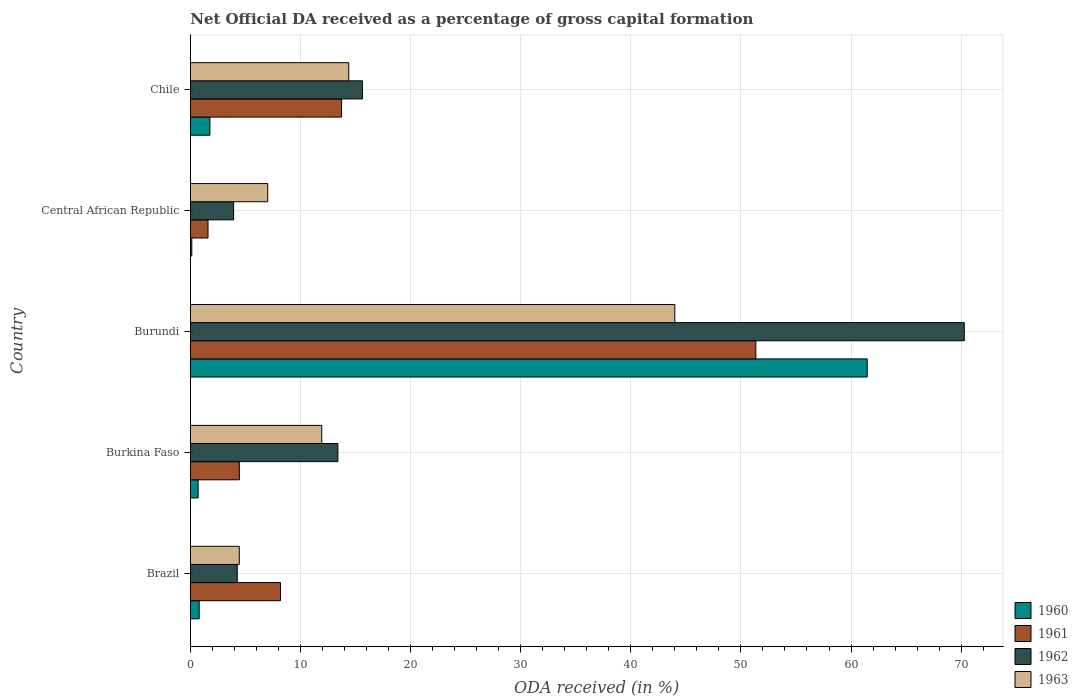How many groups of bars are there?
Offer a terse response. 5. Are the number of bars per tick equal to the number of legend labels?
Give a very brief answer. Yes. Are the number of bars on each tick of the Y-axis equal?
Make the answer very short. Yes. How many bars are there on the 1st tick from the top?
Provide a short and direct response. 4. How many bars are there on the 1st tick from the bottom?
Your response must be concise. 4. What is the label of the 1st group of bars from the top?
Offer a terse response. Chile. In how many cases, is the number of bars for a given country not equal to the number of legend labels?
Your answer should be very brief. 0. What is the net ODA received in 1960 in Burkina Faso?
Your answer should be compact. 0.71. Across all countries, what is the maximum net ODA received in 1961?
Ensure brevity in your answer.  51.36. Across all countries, what is the minimum net ODA received in 1962?
Provide a short and direct response. 3.93. In which country was the net ODA received in 1962 maximum?
Offer a very short reply. Burundi. In which country was the net ODA received in 1963 minimum?
Provide a short and direct response. Brazil. What is the total net ODA received in 1960 in the graph?
Keep it short and to the point. 64.9. What is the difference between the net ODA received in 1962 in Burundi and that in Chile?
Provide a short and direct response. 54.66. What is the difference between the net ODA received in 1962 in Chile and the net ODA received in 1960 in Burkina Faso?
Provide a succinct answer. 14.92. What is the average net ODA received in 1962 per country?
Ensure brevity in your answer.  21.5. What is the difference between the net ODA received in 1962 and net ODA received in 1963 in Burundi?
Make the answer very short. 26.29. What is the ratio of the net ODA received in 1961 in Burkina Faso to that in Chile?
Keep it short and to the point. 0.32. What is the difference between the highest and the second highest net ODA received in 1960?
Provide a short and direct response. 59.69. What is the difference between the highest and the lowest net ODA received in 1961?
Offer a very short reply. 49.75. In how many countries, is the net ODA received in 1962 greater than the average net ODA received in 1962 taken over all countries?
Keep it short and to the point. 1. Is it the case that in every country, the sum of the net ODA received in 1960 and net ODA received in 1961 is greater than the sum of net ODA received in 1962 and net ODA received in 1963?
Make the answer very short. No. What does the 4th bar from the top in Chile represents?
Your answer should be very brief. 1960. How many bars are there?
Provide a succinct answer. 20. Are the values on the major ticks of X-axis written in scientific E-notation?
Your answer should be very brief. No. Does the graph contain any zero values?
Give a very brief answer. No. Does the graph contain grids?
Give a very brief answer. Yes. How many legend labels are there?
Keep it short and to the point. 4. What is the title of the graph?
Offer a very short reply. Net Official DA received as a percentage of gross capital formation. Does "1977" appear as one of the legend labels in the graph?
Offer a terse response. No. What is the label or title of the X-axis?
Your answer should be very brief. ODA received (in %). What is the label or title of the Y-axis?
Provide a short and direct response. Country. What is the ODA received (in %) of 1960 in Brazil?
Offer a very short reply. 0.81. What is the ODA received (in %) of 1961 in Brazil?
Your answer should be compact. 8.19. What is the ODA received (in %) in 1962 in Brazil?
Offer a very short reply. 4.26. What is the ODA received (in %) in 1963 in Brazil?
Give a very brief answer. 4.45. What is the ODA received (in %) in 1960 in Burkina Faso?
Give a very brief answer. 0.71. What is the ODA received (in %) in 1961 in Burkina Faso?
Your answer should be very brief. 4.45. What is the ODA received (in %) of 1962 in Burkina Faso?
Offer a very short reply. 13.4. What is the ODA received (in %) of 1963 in Burkina Faso?
Offer a very short reply. 11.94. What is the ODA received (in %) in 1960 in Burundi?
Your answer should be very brief. 61.47. What is the ODA received (in %) of 1961 in Burundi?
Make the answer very short. 51.36. What is the ODA received (in %) in 1962 in Burundi?
Make the answer very short. 70.29. What is the ODA received (in %) in 1963 in Burundi?
Provide a succinct answer. 44. What is the ODA received (in %) of 1960 in Central African Republic?
Your answer should be very brief. 0.14. What is the ODA received (in %) of 1961 in Central African Republic?
Make the answer very short. 1.61. What is the ODA received (in %) in 1962 in Central African Republic?
Make the answer very short. 3.93. What is the ODA received (in %) in 1963 in Central African Republic?
Provide a short and direct response. 7.03. What is the ODA received (in %) of 1960 in Chile?
Offer a terse response. 1.78. What is the ODA received (in %) in 1961 in Chile?
Ensure brevity in your answer.  13.73. What is the ODA received (in %) of 1962 in Chile?
Your answer should be very brief. 15.63. What is the ODA received (in %) in 1963 in Chile?
Your answer should be compact. 14.39. Across all countries, what is the maximum ODA received (in %) in 1960?
Make the answer very short. 61.47. Across all countries, what is the maximum ODA received (in %) of 1961?
Your answer should be very brief. 51.36. Across all countries, what is the maximum ODA received (in %) in 1962?
Offer a terse response. 70.29. Across all countries, what is the minimum ODA received (in %) in 1960?
Your answer should be compact. 0.14. Across all countries, what is the minimum ODA received (in %) of 1961?
Provide a succinct answer. 1.61. Across all countries, what is the minimum ODA received (in %) in 1962?
Offer a very short reply. 3.93. Across all countries, what is the minimum ODA received (in %) in 1963?
Your response must be concise. 4.45. What is the total ODA received (in %) in 1960 in the graph?
Provide a succinct answer. 64.9. What is the total ODA received (in %) of 1961 in the graph?
Your answer should be compact. 79.35. What is the total ODA received (in %) of 1962 in the graph?
Provide a short and direct response. 107.52. What is the total ODA received (in %) in 1963 in the graph?
Your answer should be very brief. 81.81. What is the difference between the ODA received (in %) in 1960 in Brazil and that in Burkina Faso?
Provide a short and direct response. 0.1. What is the difference between the ODA received (in %) of 1961 in Brazil and that in Burkina Faso?
Offer a terse response. 3.74. What is the difference between the ODA received (in %) of 1962 in Brazil and that in Burkina Faso?
Provide a short and direct response. -9.14. What is the difference between the ODA received (in %) of 1963 in Brazil and that in Burkina Faso?
Keep it short and to the point. -7.49. What is the difference between the ODA received (in %) in 1960 in Brazil and that in Burundi?
Your answer should be compact. -60.66. What is the difference between the ODA received (in %) of 1961 in Brazil and that in Burundi?
Make the answer very short. -43.17. What is the difference between the ODA received (in %) in 1962 in Brazil and that in Burundi?
Your response must be concise. -66.02. What is the difference between the ODA received (in %) of 1963 in Brazil and that in Burundi?
Provide a short and direct response. -39.55. What is the difference between the ODA received (in %) in 1960 in Brazil and that in Central African Republic?
Provide a short and direct response. 0.67. What is the difference between the ODA received (in %) in 1961 in Brazil and that in Central African Republic?
Offer a terse response. 6.58. What is the difference between the ODA received (in %) of 1962 in Brazil and that in Central African Republic?
Provide a short and direct response. 0.33. What is the difference between the ODA received (in %) of 1963 in Brazil and that in Central African Republic?
Make the answer very short. -2.58. What is the difference between the ODA received (in %) in 1960 in Brazil and that in Chile?
Provide a short and direct response. -0.97. What is the difference between the ODA received (in %) in 1961 in Brazil and that in Chile?
Your answer should be very brief. -5.54. What is the difference between the ODA received (in %) of 1962 in Brazil and that in Chile?
Offer a very short reply. -11.37. What is the difference between the ODA received (in %) of 1963 in Brazil and that in Chile?
Offer a terse response. -9.94. What is the difference between the ODA received (in %) of 1960 in Burkina Faso and that in Burundi?
Your response must be concise. -60.76. What is the difference between the ODA received (in %) in 1961 in Burkina Faso and that in Burundi?
Keep it short and to the point. -46.9. What is the difference between the ODA received (in %) in 1962 in Burkina Faso and that in Burundi?
Your response must be concise. -56.88. What is the difference between the ODA received (in %) in 1963 in Burkina Faso and that in Burundi?
Offer a terse response. -32.06. What is the difference between the ODA received (in %) of 1960 in Burkina Faso and that in Central African Republic?
Provide a short and direct response. 0.57. What is the difference between the ODA received (in %) in 1961 in Burkina Faso and that in Central African Republic?
Make the answer very short. 2.84. What is the difference between the ODA received (in %) in 1962 in Burkina Faso and that in Central African Republic?
Offer a terse response. 9.47. What is the difference between the ODA received (in %) of 1963 in Burkina Faso and that in Central African Republic?
Offer a terse response. 4.91. What is the difference between the ODA received (in %) of 1960 in Burkina Faso and that in Chile?
Your answer should be very brief. -1.07. What is the difference between the ODA received (in %) in 1961 in Burkina Faso and that in Chile?
Your answer should be compact. -9.28. What is the difference between the ODA received (in %) of 1962 in Burkina Faso and that in Chile?
Provide a succinct answer. -2.23. What is the difference between the ODA received (in %) in 1963 in Burkina Faso and that in Chile?
Offer a very short reply. -2.45. What is the difference between the ODA received (in %) of 1960 in Burundi and that in Central African Republic?
Ensure brevity in your answer.  61.33. What is the difference between the ODA received (in %) in 1961 in Burundi and that in Central African Republic?
Offer a very short reply. 49.75. What is the difference between the ODA received (in %) in 1962 in Burundi and that in Central African Republic?
Provide a succinct answer. 66.35. What is the difference between the ODA received (in %) of 1963 in Burundi and that in Central African Republic?
Keep it short and to the point. 36.97. What is the difference between the ODA received (in %) in 1960 in Burundi and that in Chile?
Offer a terse response. 59.69. What is the difference between the ODA received (in %) in 1961 in Burundi and that in Chile?
Your answer should be very brief. 37.62. What is the difference between the ODA received (in %) in 1962 in Burundi and that in Chile?
Keep it short and to the point. 54.66. What is the difference between the ODA received (in %) in 1963 in Burundi and that in Chile?
Keep it short and to the point. 29.61. What is the difference between the ODA received (in %) of 1960 in Central African Republic and that in Chile?
Provide a succinct answer. -1.64. What is the difference between the ODA received (in %) in 1961 in Central African Republic and that in Chile?
Offer a very short reply. -12.12. What is the difference between the ODA received (in %) of 1962 in Central African Republic and that in Chile?
Offer a very short reply. -11.7. What is the difference between the ODA received (in %) in 1963 in Central African Republic and that in Chile?
Offer a very short reply. -7.36. What is the difference between the ODA received (in %) of 1960 in Brazil and the ODA received (in %) of 1961 in Burkina Faso?
Your answer should be very brief. -3.65. What is the difference between the ODA received (in %) of 1960 in Brazil and the ODA received (in %) of 1962 in Burkina Faso?
Make the answer very short. -12.6. What is the difference between the ODA received (in %) in 1960 in Brazil and the ODA received (in %) in 1963 in Burkina Faso?
Make the answer very short. -11.13. What is the difference between the ODA received (in %) of 1961 in Brazil and the ODA received (in %) of 1962 in Burkina Faso?
Your answer should be compact. -5.21. What is the difference between the ODA received (in %) in 1961 in Brazil and the ODA received (in %) in 1963 in Burkina Faso?
Your response must be concise. -3.75. What is the difference between the ODA received (in %) of 1962 in Brazil and the ODA received (in %) of 1963 in Burkina Faso?
Your answer should be very brief. -7.67. What is the difference between the ODA received (in %) of 1960 in Brazil and the ODA received (in %) of 1961 in Burundi?
Ensure brevity in your answer.  -50.55. What is the difference between the ODA received (in %) in 1960 in Brazil and the ODA received (in %) in 1962 in Burundi?
Offer a terse response. -69.48. What is the difference between the ODA received (in %) in 1960 in Brazil and the ODA received (in %) in 1963 in Burundi?
Your answer should be compact. -43.19. What is the difference between the ODA received (in %) of 1961 in Brazil and the ODA received (in %) of 1962 in Burundi?
Your response must be concise. -62.09. What is the difference between the ODA received (in %) of 1961 in Brazil and the ODA received (in %) of 1963 in Burundi?
Your response must be concise. -35.81. What is the difference between the ODA received (in %) in 1962 in Brazil and the ODA received (in %) in 1963 in Burundi?
Your answer should be very brief. -39.74. What is the difference between the ODA received (in %) of 1960 in Brazil and the ODA received (in %) of 1961 in Central African Republic?
Ensure brevity in your answer.  -0.8. What is the difference between the ODA received (in %) of 1960 in Brazil and the ODA received (in %) of 1962 in Central African Republic?
Your answer should be very brief. -3.13. What is the difference between the ODA received (in %) in 1960 in Brazil and the ODA received (in %) in 1963 in Central African Republic?
Offer a very short reply. -6.22. What is the difference between the ODA received (in %) in 1961 in Brazil and the ODA received (in %) in 1962 in Central African Republic?
Offer a terse response. 4.26. What is the difference between the ODA received (in %) of 1961 in Brazil and the ODA received (in %) of 1963 in Central African Republic?
Provide a succinct answer. 1.16. What is the difference between the ODA received (in %) in 1962 in Brazil and the ODA received (in %) in 1963 in Central African Republic?
Give a very brief answer. -2.77. What is the difference between the ODA received (in %) of 1960 in Brazil and the ODA received (in %) of 1961 in Chile?
Your answer should be very brief. -12.93. What is the difference between the ODA received (in %) of 1960 in Brazil and the ODA received (in %) of 1962 in Chile?
Ensure brevity in your answer.  -14.82. What is the difference between the ODA received (in %) in 1960 in Brazil and the ODA received (in %) in 1963 in Chile?
Offer a very short reply. -13.58. What is the difference between the ODA received (in %) in 1961 in Brazil and the ODA received (in %) in 1962 in Chile?
Your response must be concise. -7.44. What is the difference between the ODA received (in %) in 1961 in Brazil and the ODA received (in %) in 1963 in Chile?
Keep it short and to the point. -6.2. What is the difference between the ODA received (in %) of 1962 in Brazil and the ODA received (in %) of 1963 in Chile?
Your answer should be very brief. -10.12. What is the difference between the ODA received (in %) in 1960 in Burkina Faso and the ODA received (in %) in 1961 in Burundi?
Make the answer very short. -50.65. What is the difference between the ODA received (in %) of 1960 in Burkina Faso and the ODA received (in %) of 1962 in Burundi?
Your answer should be compact. -69.58. What is the difference between the ODA received (in %) in 1960 in Burkina Faso and the ODA received (in %) in 1963 in Burundi?
Provide a succinct answer. -43.29. What is the difference between the ODA received (in %) of 1961 in Burkina Faso and the ODA received (in %) of 1962 in Burundi?
Provide a short and direct response. -65.83. What is the difference between the ODA received (in %) of 1961 in Burkina Faso and the ODA received (in %) of 1963 in Burundi?
Your response must be concise. -39.55. What is the difference between the ODA received (in %) of 1962 in Burkina Faso and the ODA received (in %) of 1963 in Burundi?
Keep it short and to the point. -30.6. What is the difference between the ODA received (in %) in 1960 in Burkina Faso and the ODA received (in %) in 1961 in Central African Republic?
Make the answer very short. -0.9. What is the difference between the ODA received (in %) in 1960 in Burkina Faso and the ODA received (in %) in 1962 in Central African Republic?
Offer a very short reply. -3.22. What is the difference between the ODA received (in %) in 1960 in Burkina Faso and the ODA received (in %) in 1963 in Central African Republic?
Your response must be concise. -6.32. What is the difference between the ODA received (in %) of 1961 in Burkina Faso and the ODA received (in %) of 1962 in Central African Republic?
Your response must be concise. 0.52. What is the difference between the ODA received (in %) in 1961 in Burkina Faso and the ODA received (in %) in 1963 in Central African Republic?
Ensure brevity in your answer.  -2.58. What is the difference between the ODA received (in %) in 1962 in Burkina Faso and the ODA received (in %) in 1963 in Central African Republic?
Ensure brevity in your answer.  6.37. What is the difference between the ODA received (in %) of 1960 in Burkina Faso and the ODA received (in %) of 1961 in Chile?
Ensure brevity in your answer.  -13.02. What is the difference between the ODA received (in %) of 1960 in Burkina Faso and the ODA received (in %) of 1962 in Chile?
Offer a terse response. -14.92. What is the difference between the ODA received (in %) in 1960 in Burkina Faso and the ODA received (in %) in 1963 in Chile?
Provide a short and direct response. -13.68. What is the difference between the ODA received (in %) in 1961 in Burkina Faso and the ODA received (in %) in 1962 in Chile?
Keep it short and to the point. -11.18. What is the difference between the ODA received (in %) in 1961 in Burkina Faso and the ODA received (in %) in 1963 in Chile?
Offer a very short reply. -9.93. What is the difference between the ODA received (in %) in 1962 in Burkina Faso and the ODA received (in %) in 1963 in Chile?
Provide a succinct answer. -0.98. What is the difference between the ODA received (in %) in 1960 in Burundi and the ODA received (in %) in 1961 in Central African Republic?
Your answer should be compact. 59.86. What is the difference between the ODA received (in %) in 1960 in Burundi and the ODA received (in %) in 1962 in Central African Republic?
Make the answer very short. 57.54. What is the difference between the ODA received (in %) in 1960 in Burundi and the ODA received (in %) in 1963 in Central African Republic?
Offer a very short reply. 54.44. What is the difference between the ODA received (in %) of 1961 in Burundi and the ODA received (in %) of 1962 in Central African Republic?
Make the answer very short. 47.42. What is the difference between the ODA received (in %) in 1961 in Burundi and the ODA received (in %) in 1963 in Central African Republic?
Make the answer very short. 44.33. What is the difference between the ODA received (in %) in 1962 in Burundi and the ODA received (in %) in 1963 in Central African Republic?
Make the answer very short. 63.25. What is the difference between the ODA received (in %) of 1960 in Burundi and the ODA received (in %) of 1961 in Chile?
Give a very brief answer. 47.73. What is the difference between the ODA received (in %) in 1960 in Burundi and the ODA received (in %) in 1962 in Chile?
Provide a succinct answer. 45.84. What is the difference between the ODA received (in %) of 1960 in Burundi and the ODA received (in %) of 1963 in Chile?
Give a very brief answer. 47.08. What is the difference between the ODA received (in %) in 1961 in Burundi and the ODA received (in %) in 1962 in Chile?
Your answer should be very brief. 35.73. What is the difference between the ODA received (in %) in 1961 in Burundi and the ODA received (in %) in 1963 in Chile?
Provide a short and direct response. 36.97. What is the difference between the ODA received (in %) of 1962 in Burundi and the ODA received (in %) of 1963 in Chile?
Ensure brevity in your answer.  55.9. What is the difference between the ODA received (in %) in 1960 in Central African Republic and the ODA received (in %) in 1961 in Chile?
Your response must be concise. -13.6. What is the difference between the ODA received (in %) in 1960 in Central African Republic and the ODA received (in %) in 1962 in Chile?
Ensure brevity in your answer.  -15.49. What is the difference between the ODA received (in %) in 1960 in Central African Republic and the ODA received (in %) in 1963 in Chile?
Your response must be concise. -14.25. What is the difference between the ODA received (in %) in 1961 in Central African Republic and the ODA received (in %) in 1962 in Chile?
Offer a terse response. -14.02. What is the difference between the ODA received (in %) of 1961 in Central African Republic and the ODA received (in %) of 1963 in Chile?
Provide a succinct answer. -12.78. What is the difference between the ODA received (in %) of 1962 in Central African Republic and the ODA received (in %) of 1963 in Chile?
Make the answer very short. -10.45. What is the average ODA received (in %) in 1960 per country?
Provide a short and direct response. 12.98. What is the average ODA received (in %) of 1961 per country?
Keep it short and to the point. 15.87. What is the average ODA received (in %) of 1962 per country?
Your answer should be compact. 21.5. What is the average ODA received (in %) in 1963 per country?
Your answer should be very brief. 16.36. What is the difference between the ODA received (in %) of 1960 and ODA received (in %) of 1961 in Brazil?
Give a very brief answer. -7.38. What is the difference between the ODA received (in %) of 1960 and ODA received (in %) of 1962 in Brazil?
Keep it short and to the point. -3.46. What is the difference between the ODA received (in %) of 1960 and ODA received (in %) of 1963 in Brazil?
Provide a succinct answer. -3.64. What is the difference between the ODA received (in %) in 1961 and ODA received (in %) in 1962 in Brazil?
Make the answer very short. 3.93. What is the difference between the ODA received (in %) in 1961 and ODA received (in %) in 1963 in Brazil?
Give a very brief answer. 3.74. What is the difference between the ODA received (in %) of 1962 and ODA received (in %) of 1963 in Brazil?
Give a very brief answer. -0.18. What is the difference between the ODA received (in %) of 1960 and ODA received (in %) of 1961 in Burkina Faso?
Offer a terse response. -3.74. What is the difference between the ODA received (in %) in 1960 and ODA received (in %) in 1962 in Burkina Faso?
Your answer should be compact. -12.69. What is the difference between the ODA received (in %) of 1960 and ODA received (in %) of 1963 in Burkina Faso?
Provide a succinct answer. -11.23. What is the difference between the ODA received (in %) of 1961 and ODA received (in %) of 1962 in Burkina Faso?
Your answer should be compact. -8.95. What is the difference between the ODA received (in %) of 1961 and ODA received (in %) of 1963 in Burkina Faso?
Give a very brief answer. -7.48. What is the difference between the ODA received (in %) of 1962 and ODA received (in %) of 1963 in Burkina Faso?
Your answer should be compact. 1.47. What is the difference between the ODA received (in %) in 1960 and ODA received (in %) in 1961 in Burundi?
Offer a very short reply. 10.11. What is the difference between the ODA received (in %) of 1960 and ODA received (in %) of 1962 in Burundi?
Provide a succinct answer. -8.82. What is the difference between the ODA received (in %) in 1960 and ODA received (in %) in 1963 in Burundi?
Your answer should be compact. 17.47. What is the difference between the ODA received (in %) of 1961 and ODA received (in %) of 1962 in Burundi?
Your answer should be very brief. -18.93. What is the difference between the ODA received (in %) in 1961 and ODA received (in %) in 1963 in Burundi?
Offer a terse response. 7.36. What is the difference between the ODA received (in %) in 1962 and ODA received (in %) in 1963 in Burundi?
Give a very brief answer. 26.29. What is the difference between the ODA received (in %) in 1960 and ODA received (in %) in 1961 in Central African Republic?
Provide a succinct answer. -1.47. What is the difference between the ODA received (in %) of 1960 and ODA received (in %) of 1962 in Central African Republic?
Make the answer very short. -3.8. What is the difference between the ODA received (in %) of 1960 and ODA received (in %) of 1963 in Central African Republic?
Offer a terse response. -6.89. What is the difference between the ODA received (in %) in 1961 and ODA received (in %) in 1962 in Central African Republic?
Your answer should be very brief. -2.32. What is the difference between the ODA received (in %) of 1961 and ODA received (in %) of 1963 in Central African Republic?
Your answer should be very brief. -5.42. What is the difference between the ODA received (in %) of 1962 and ODA received (in %) of 1963 in Central African Republic?
Ensure brevity in your answer.  -3.1. What is the difference between the ODA received (in %) of 1960 and ODA received (in %) of 1961 in Chile?
Make the answer very short. -11.96. What is the difference between the ODA received (in %) of 1960 and ODA received (in %) of 1962 in Chile?
Provide a succinct answer. -13.85. What is the difference between the ODA received (in %) of 1960 and ODA received (in %) of 1963 in Chile?
Your answer should be very brief. -12.61. What is the difference between the ODA received (in %) in 1961 and ODA received (in %) in 1962 in Chile?
Provide a short and direct response. -1.89. What is the difference between the ODA received (in %) of 1961 and ODA received (in %) of 1963 in Chile?
Provide a succinct answer. -0.65. What is the difference between the ODA received (in %) in 1962 and ODA received (in %) in 1963 in Chile?
Offer a terse response. 1.24. What is the ratio of the ODA received (in %) in 1960 in Brazil to that in Burkina Faso?
Your answer should be compact. 1.14. What is the ratio of the ODA received (in %) in 1961 in Brazil to that in Burkina Faso?
Offer a terse response. 1.84. What is the ratio of the ODA received (in %) of 1962 in Brazil to that in Burkina Faso?
Provide a short and direct response. 0.32. What is the ratio of the ODA received (in %) in 1963 in Brazil to that in Burkina Faso?
Keep it short and to the point. 0.37. What is the ratio of the ODA received (in %) in 1960 in Brazil to that in Burundi?
Your answer should be very brief. 0.01. What is the ratio of the ODA received (in %) in 1961 in Brazil to that in Burundi?
Ensure brevity in your answer.  0.16. What is the ratio of the ODA received (in %) in 1962 in Brazil to that in Burundi?
Your response must be concise. 0.06. What is the ratio of the ODA received (in %) in 1963 in Brazil to that in Burundi?
Provide a succinct answer. 0.1. What is the ratio of the ODA received (in %) in 1960 in Brazil to that in Central African Republic?
Offer a very short reply. 5.93. What is the ratio of the ODA received (in %) in 1961 in Brazil to that in Central African Republic?
Offer a terse response. 5.09. What is the ratio of the ODA received (in %) in 1962 in Brazil to that in Central African Republic?
Offer a terse response. 1.08. What is the ratio of the ODA received (in %) of 1963 in Brazil to that in Central African Republic?
Give a very brief answer. 0.63. What is the ratio of the ODA received (in %) of 1960 in Brazil to that in Chile?
Provide a succinct answer. 0.45. What is the ratio of the ODA received (in %) of 1961 in Brazil to that in Chile?
Offer a very short reply. 0.6. What is the ratio of the ODA received (in %) of 1962 in Brazil to that in Chile?
Your response must be concise. 0.27. What is the ratio of the ODA received (in %) of 1963 in Brazil to that in Chile?
Your response must be concise. 0.31. What is the ratio of the ODA received (in %) of 1960 in Burkina Faso to that in Burundi?
Ensure brevity in your answer.  0.01. What is the ratio of the ODA received (in %) of 1961 in Burkina Faso to that in Burundi?
Your response must be concise. 0.09. What is the ratio of the ODA received (in %) in 1962 in Burkina Faso to that in Burundi?
Make the answer very short. 0.19. What is the ratio of the ODA received (in %) in 1963 in Burkina Faso to that in Burundi?
Your response must be concise. 0.27. What is the ratio of the ODA received (in %) in 1960 in Burkina Faso to that in Central African Republic?
Keep it short and to the point. 5.21. What is the ratio of the ODA received (in %) of 1961 in Burkina Faso to that in Central African Republic?
Keep it short and to the point. 2.77. What is the ratio of the ODA received (in %) in 1962 in Burkina Faso to that in Central African Republic?
Your response must be concise. 3.41. What is the ratio of the ODA received (in %) in 1963 in Burkina Faso to that in Central African Republic?
Make the answer very short. 1.7. What is the ratio of the ODA received (in %) in 1960 in Burkina Faso to that in Chile?
Give a very brief answer. 0.4. What is the ratio of the ODA received (in %) in 1961 in Burkina Faso to that in Chile?
Ensure brevity in your answer.  0.32. What is the ratio of the ODA received (in %) in 1962 in Burkina Faso to that in Chile?
Offer a terse response. 0.86. What is the ratio of the ODA received (in %) in 1963 in Burkina Faso to that in Chile?
Make the answer very short. 0.83. What is the ratio of the ODA received (in %) in 1960 in Burundi to that in Central African Republic?
Offer a terse response. 451.25. What is the ratio of the ODA received (in %) in 1961 in Burundi to that in Central African Republic?
Provide a short and direct response. 31.91. What is the ratio of the ODA received (in %) of 1962 in Burundi to that in Central African Republic?
Your answer should be very brief. 17.87. What is the ratio of the ODA received (in %) of 1963 in Burundi to that in Central African Republic?
Ensure brevity in your answer.  6.26. What is the ratio of the ODA received (in %) of 1960 in Burundi to that in Chile?
Offer a terse response. 34.55. What is the ratio of the ODA received (in %) in 1961 in Burundi to that in Chile?
Provide a short and direct response. 3.74. What is the ratio of the ODA received (in %) in 1962 in Burundi to that in Chile?
Offer a terse response. 4.5. What is the ratio of the ODA received (in %) of 1963 in Burundi to that in Chile?
Provide a short and direct response. 3.06. What is the ratio of the ODA received (in %) of 1960 in Central African Republic to that in Chile?
Provide a succinct answer. 0.08. What is the ratio of the ODA received (in %) in 1961 in Central African Republic to that in Chile?
Offer a terse response. 0.12. What is the ratio of the ODA received (in %) in 1962 in Central African Republic to that in Chile?
Your answer should be compact. 0.25. What is the ratio of the ODA received (in %) of 1963 in Central African Republic to that in Chile?
Your answer should be compact. 0.49. What is the difference between the highest and the second highest ODA received (in %) in 1960?
Give a very brief answer. 59.69. What is the difference between the highest and the second highest ODA received (in %) in 1961?
Offer a very short reply. 37.62. What is the difference between the highest and the second highest ODA received (in %) of 1962?
Provide a short and direct response. 54.66. What is the difference between the highest and the second highest ODA received (in %) in 1963?
Offer a very short reply. 29.61. What is the difference between the highest and the lowest ODA received (in %) of 1960?
Ensure brevity in your answer.  61.33. What is the difference between the highest and the lowest ODA received (in %) of 1961?
Make the answer very short. 49.75. What is the difference between the highest and the lowest ODA received (in %) in 1962?
Provide a short and direct response. 66.35. What is the difference between the highest and the lowest ODA received (in %) in 1963?
Provide a succinct answer. 39.55. 